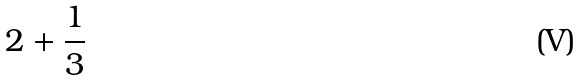<formula> <loc_0><loc_0><loc_500><loc_500>2 + \frac { 1 } { 3 }</formula> 